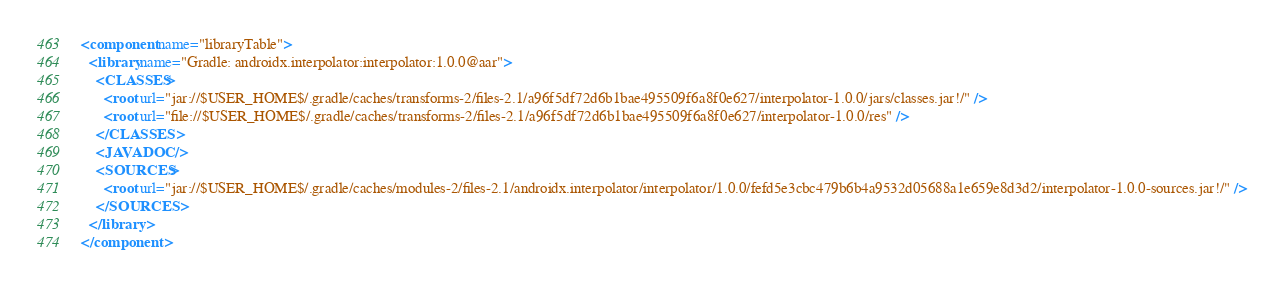<code> <loc_0><loc_0><loc_500><loc_500><_XML_><component name="libraryTable">
  <library name="Gradle: androidx.interpolator:interpolator:1.0.0@aar">
    <CLASSES>
      <root url="jar://$USER_HOME$/.gradle/caches/transforms-2/files-2.1/a96f5df72d6b1bae495509f6a8f0e627/interpolator-1.0.0/jars/classes.jar!/" />
      <root url="file://$USER_HOME$/.gradle/caches/transforms-2/files-2.1/a96f5df72d6b1bae495509f6a8f0e627/interpolator-1.0.0/res" />
    </CLASSES>
    <JAVADOC />
    <SOURCES>
      <root url="jar://$USER_HOME$/.gradle/caches/modules-2/files-2.1/androidx.interpolator/interpolator/1.0.0/fefd5e3cbc479b6b4a9532d05688a1e659e8d3d2/interpolator-1.0.0-sources.jar!/" />
    </SOURCES>
  </library>
</component></code> 